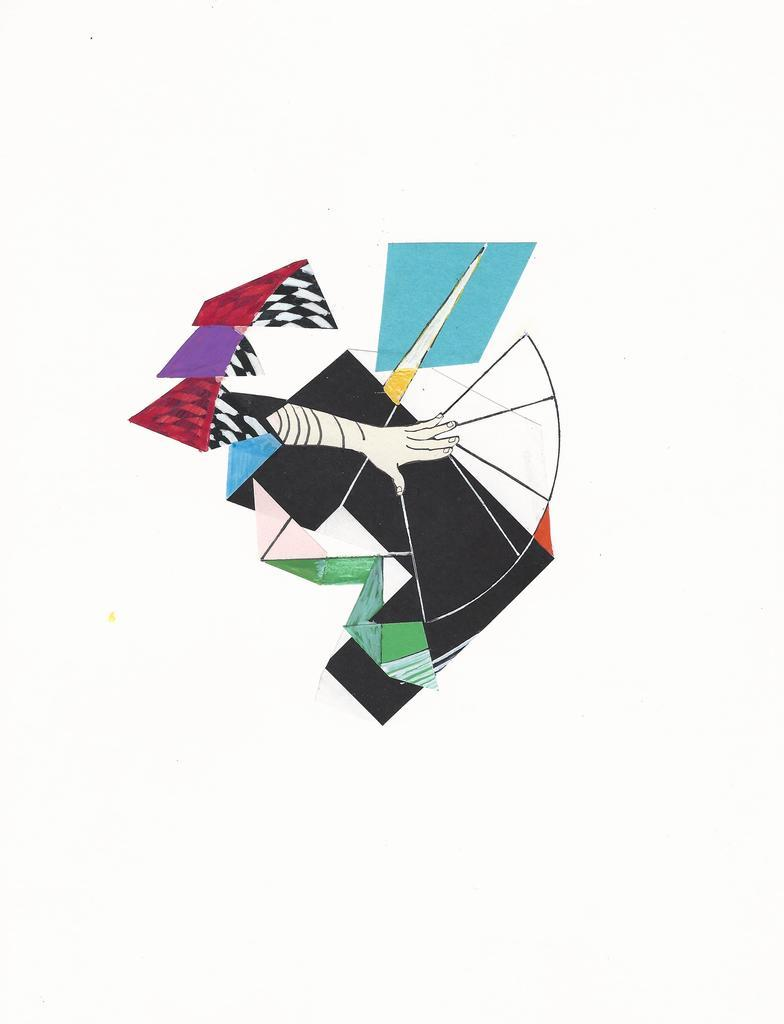What is the main subject of the image? There is a painting in the image. Can you describe the painting? The painting is colorful. What is depicted within the painting? There is a hand depicted in the painting. What color is the background of the image? The background of the image is white. How many deer can be seen in the painting? There are no deer present in the painting; it features a hand. What type of suit is the person wearing in the painting? There is no person wearing a suit in the painting; it only depicts a hand. 